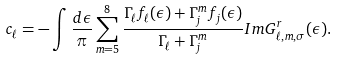<formula> <loc_0><loc_0><loc_500><loc_500>c _ { \ell } = - \int \frac { d \epsilon } { \pi } \sum ^ { 8 } _ { m = 5 } \frac { \Gamma _ { \ell } f _ { \ell } ( \epsilon ) + \Gamma ^ { m } _ { j } f _ { j } ( \epsilon ) } { \Gamma _ { \ell } + \Gamma ^ { m } _ { j } } I m G ^ { r } _ { \ell , m , \sigma } ( \epsilon ) .</formula> 